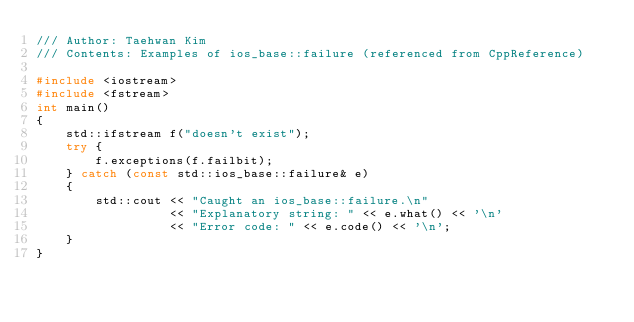Convert code to text. <code><loc_0><loc_0><loc_500><loc_500><_C++_>/// Author: Taehwan Kim
/// Contents: Examples of ios_base::failure (referenced from CppReference)

#include <iostream>
#include <fstream>
int main()
{
    std::ifstream f("doesn't exist");
    try {
        f.exceptions(f.failbit);
    } catch (const std::ios_base::failure& e)
    {
        std::cout << "Caught an ios_base::failure.\n"
                  << "Explanatory string: " << e.what() << '\n'
                  << "Error code: " << e.code() << '\n';
    }
}</code> 